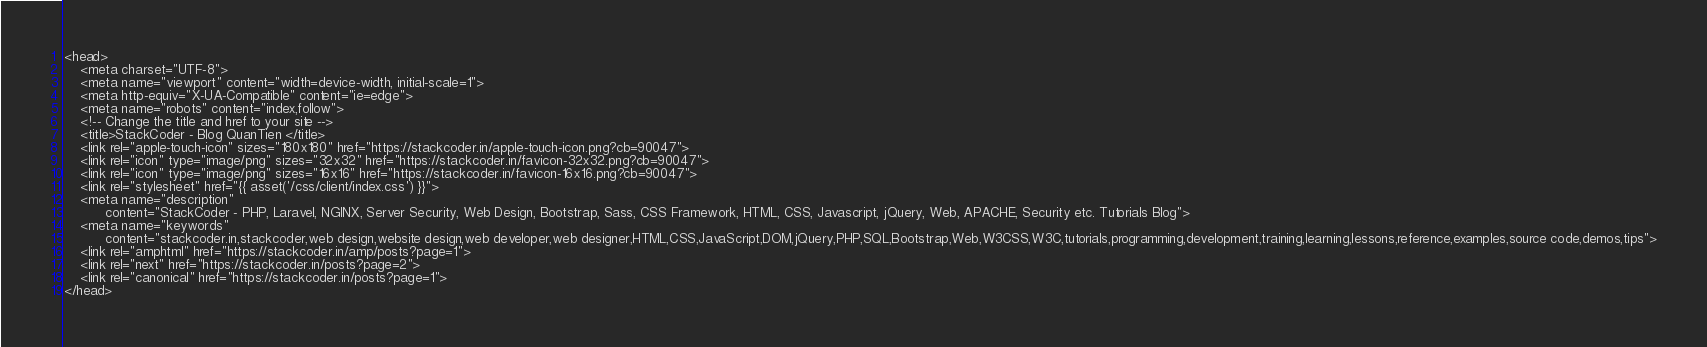Convert code to text. <code><loc_0><loc_0><loc_500><loc_500><_PHP_><head>
    <meta charset="UTF-8">
    <meta name="viewport" content="width=device-width, initial-scale=1">
    <meta http-equiv="X-UA-Compatible" content="ie=edge">
    <meta name="robots" content="index,follow">
    <!-- Change the title and href to your site -->
    <title>StackCoder - Blog QuanTien </title>
    <link rel="apple-touch-icon" sizes="180x180" href="https://stackcoder.in/apple-touch-icon.png?cb=90047">
    <link rel="icon" type="image/png" sizes="32x32" href="https://stackcoder.in/favicon-32x32.png?cb=90047">
    <link rel="icon" type="image/png" sizes="16x16" href="https://stackcoder.in/favicon-16x16.png?cb=90047">
    <link rel="stylesheet" href="{{ asset('/css/client/index.css') }}">
    <meta name="description"
          content="StackCoder - PHP, Laravel, NGINX, Server Security, Web Design, Bootstrap, Sass, CSS Framework, HTML, CSS, Javascript, jQuery, Web, APACHE, Security etc. Tutorials Blog">
    <meta name="keywords"
          content="stackcoder.in,stackcoder,web design,website design,web developer,web designer,HTML,CSS,JavaScript,DOM,jQuery,PHP,SQL,Bootstrap,Web,W3CSS,W3C,tutorials,programming,development,training,learning,lessons,reference,examples,source code,demos,tips">
    <link rel="amphtml" href="https://stackcoder.in/amp/posts?page=1">
    <link rel="next" href="https://stackcoder.in/posts?page=2">
    <link rel="canonical" href="https://stackcoder.in/posts?page=1">
</head>
</code> 